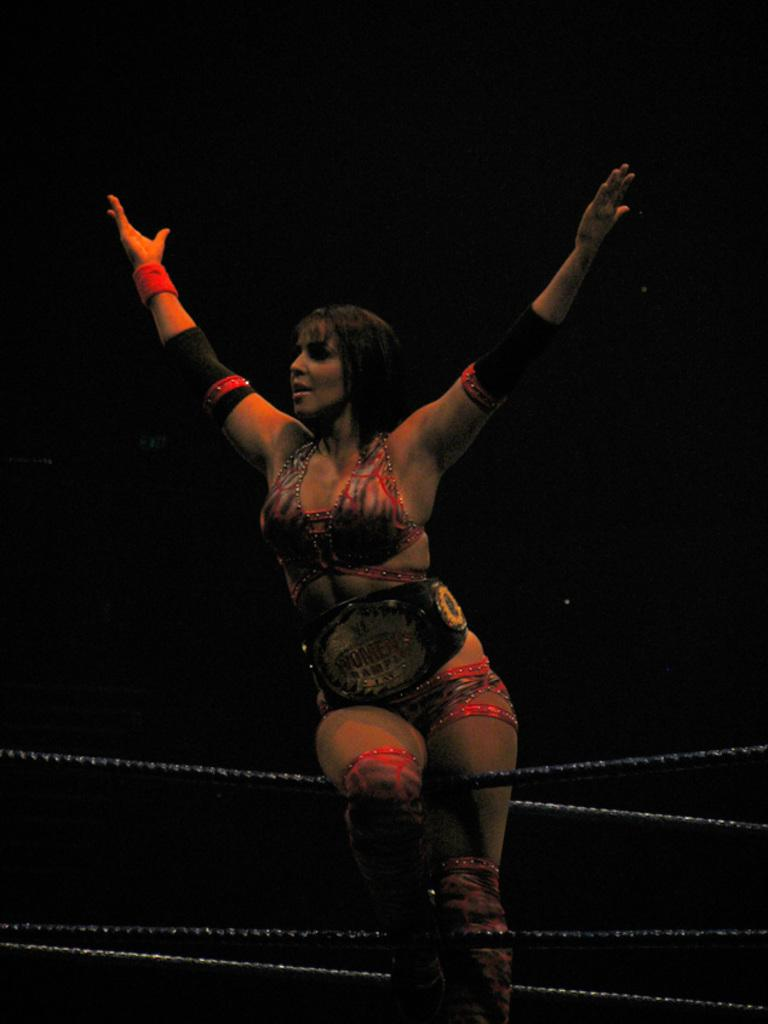What is the main subject of the image? There is a person standing in the image. What objects can be seen in the image besides the person? There are ropes in the image. What can be observed about the background of the image? The background of the image is dark. What type of suit is the person wearing in the image? There is no suit visible in the image; the person is not wearing any clothing mentioned in the facts. 